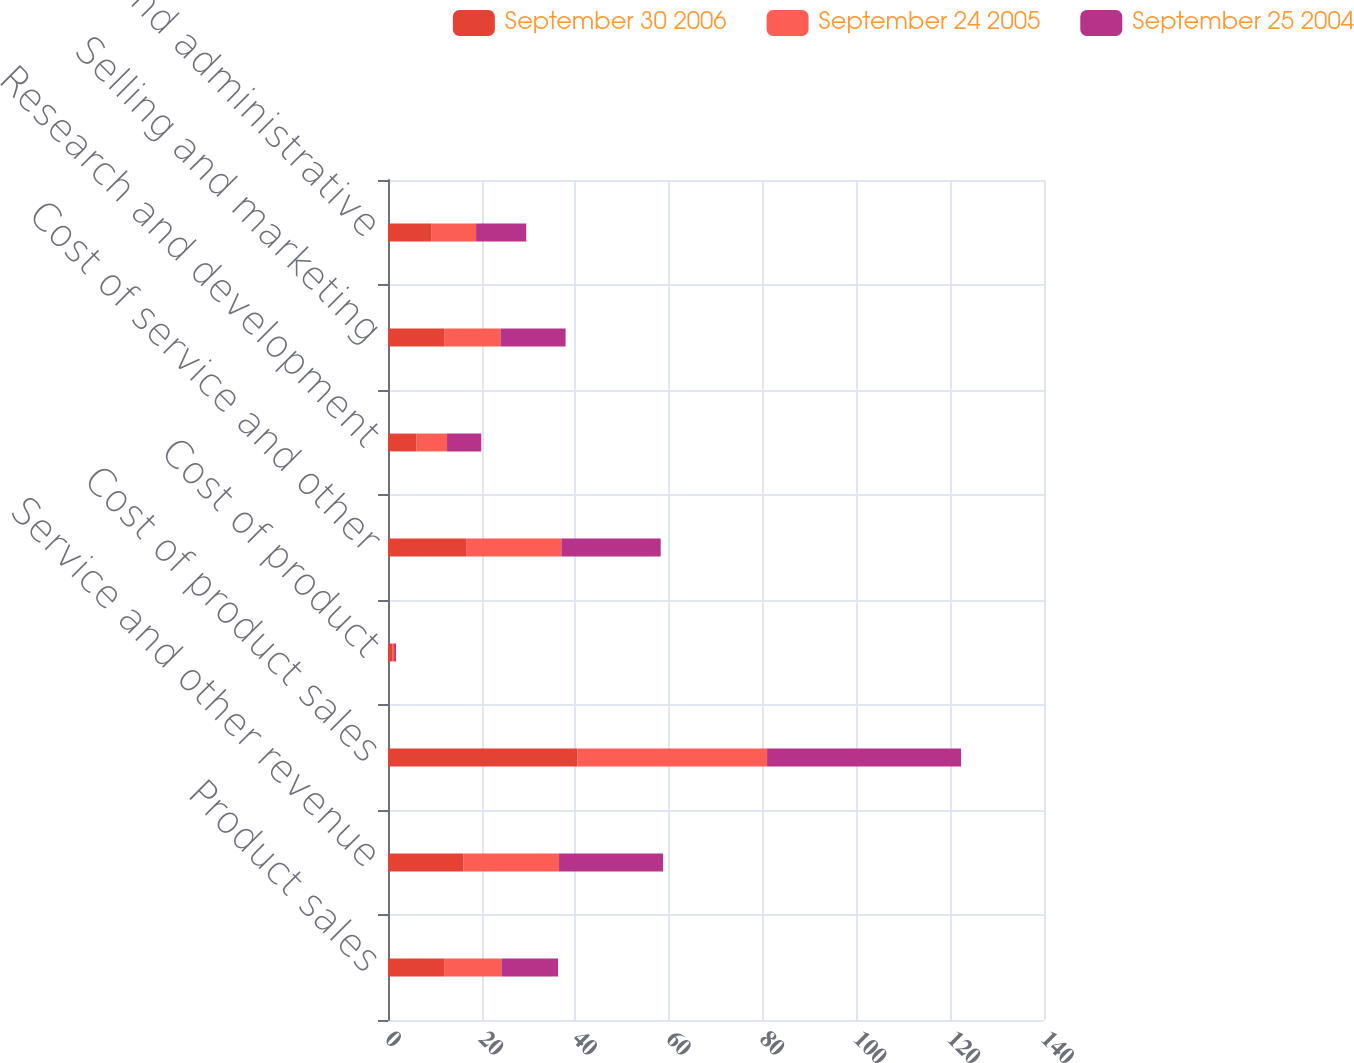Convert chart. <chart><loc_0><loc_0><loc_500><loc_500><stacked_bar_chart><ecel><fcel>Product sales<fcel>Service and other revenue<fcel>Cost of product sales<fcel>Cost of product<fcel>Cost of service and other<fcel>Research and development<fcel>Selling and marketing<fcel>General and administrative<nl><fcel>September 30 2006<fcel>12.1<fcel>16.1<fcel>40.4<fcel>1<fcel>16.8<fcel>6.1<fcel>12.1<fcel>9.2<nl><fcel>September 24 2005<fcel>12.1<fcel>20.4<fcel>40.5<fcel>0.3<fcel>20.2<fcel>6.5<fcel>11.9<fcel>9.6<nl><fcel>September 25 2004<fcel>12.1<fcel>22.2<fcel>41.4<fcel>0.4<fcel>21.2<fcel>7.3<fcel>13.9<fcel>10.7<nl></chart> 